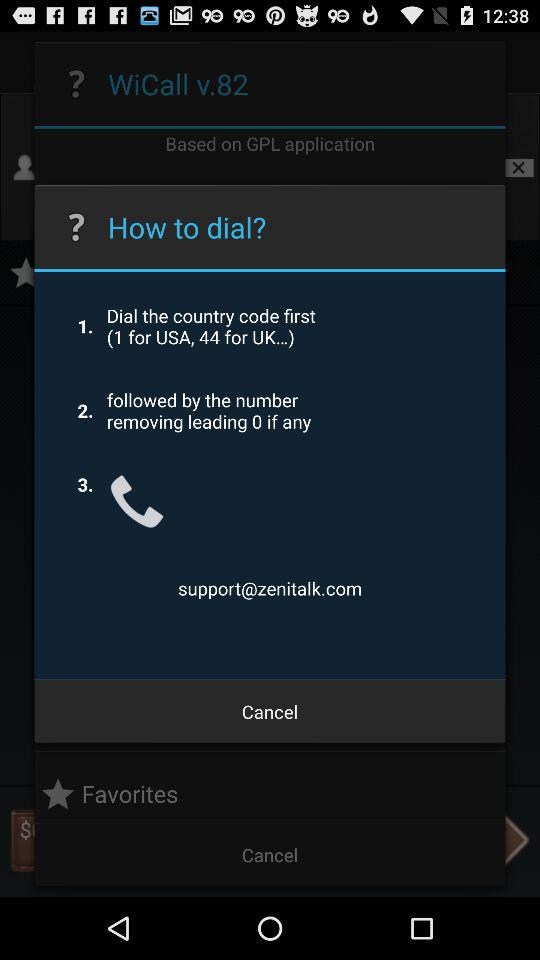How many steps are there in the instructions?
Answer the question using a single word or phrase. 3 